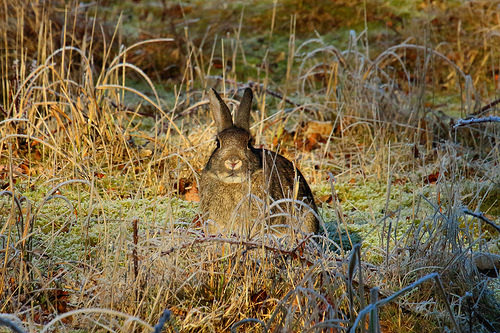<image>
Can you confirm if the bunny is above the field? No. The bunny is not positioned above the field. The vertical arrangement shows a different relationship. Where is the rabbit in relation to the grass? Is it behind the grass? Yes. From this viewpoint, the rabbit is positioned behind the grass, with the grass partially or fully occluding the rabbit. 